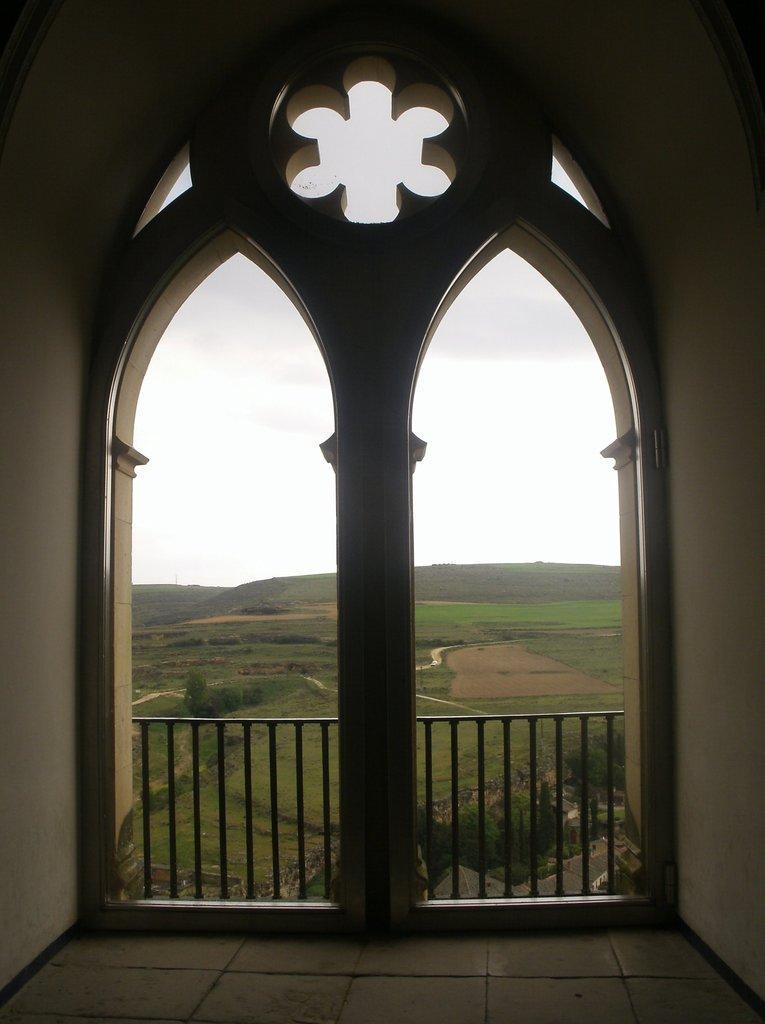How would you summarize this image in a sentence or two? In this image we can see the building and we can see the metal railing and there are some trees and grass on the ground and in the background, we can see the mountains and the sky. 